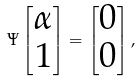Convert formula to latex. <formula><loc_0><loc_0><loc_500><loc_500>\Psi \begin{bmatrix} \alpha \\ 1 \end{bmatrix} = \begin{bmatrix} 0 \\ 0 \end{bmatrix} ,</formula> 